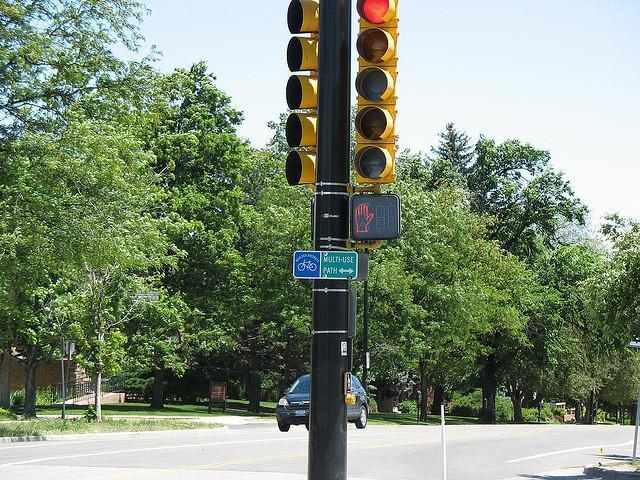How many traffic lights can you see?
Give a very brief answer. 2. 